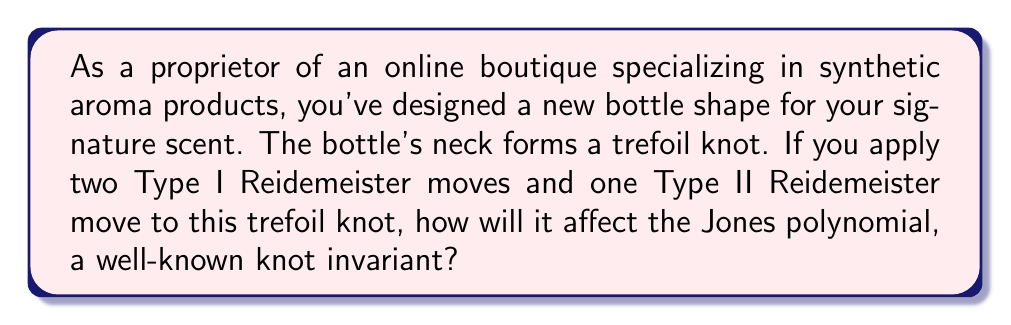Provide a solution to this math problem. Let's approach this step-by-step:

1) First, recall that the Jones polynomial is a knot invariant. This means it remains unchanged under any sequence of Reidemeister moves.

2) The Reidemeister moves are:
   - Type I: Twist or untwist in either direction
   - Type II: Move one loop entirely over another
   - Type III: Move a strand from one side of a crossing to the other

3) In this case, we're applying:
   - Two Type I moves
   - One Type II move

4) Importantly, regardless of how these moves are applied, they do not change the fundamental structure of the knot. The trefoil knot remains a trefoil knot after these operations.

5) The Jones polynomial for a trefoil knot is:

   $$V(t) = t + t^3 - t^4$$

6) Since the Jones polynomial is invariant under Reidemeister moves, and the knot remains a trefoil after the moves, the Jones polynomial will remain unchanged.

7) Therefore, after applying the specified Reidemeister moves, the Jones polynomial will still be:

   $$V(t) = t + t^3 - t^4$$
Answer: The Jones polynomial remains unchanged: $V(t) = t + t^3 - t^4$ 